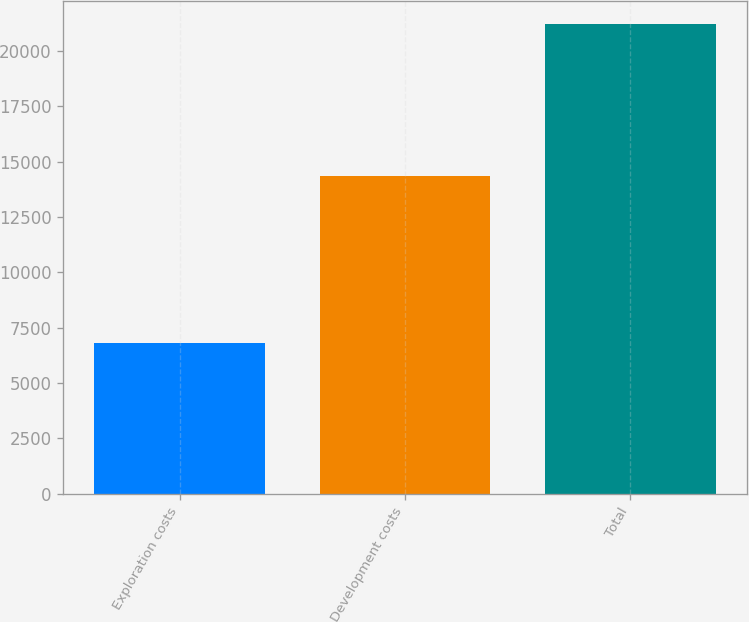Convert chart to OTSL. <chart><loc_0><loc_0><loc_500><loc_500><bar_chart><fcel>Exploration costs<fcel>Development costs<fcel>Total<nl><fcel>6820<fcel>14369<fcel>21195<nl></chart> 